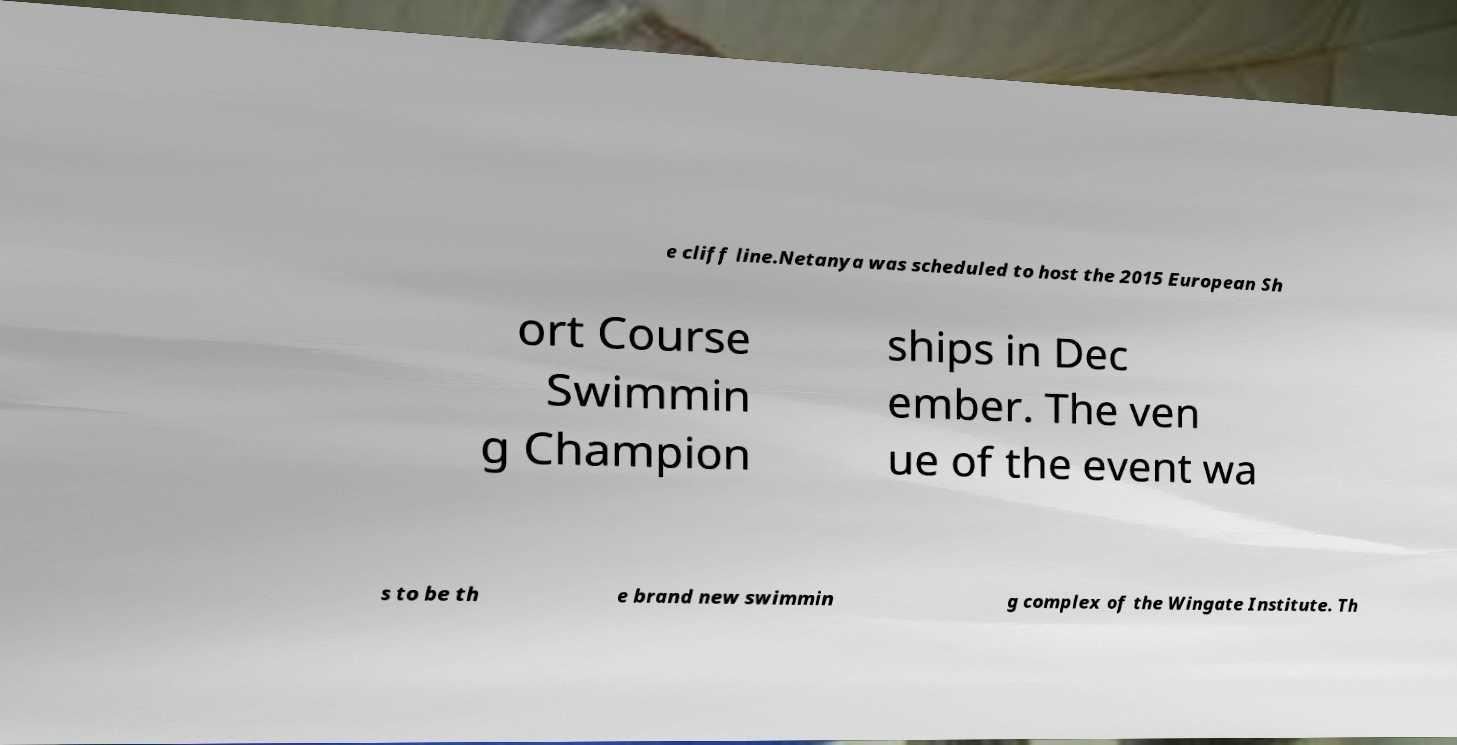Please read and relay the text visible in this image. What does it say? e cliff line.Netanya was scheduled to host the 2015 European Sh ort Course Swimmin g Champion ships in Dec ember. The ven ue of the event wa s to be th e brand new swimmin g complex of the Wingate Institute. Th 